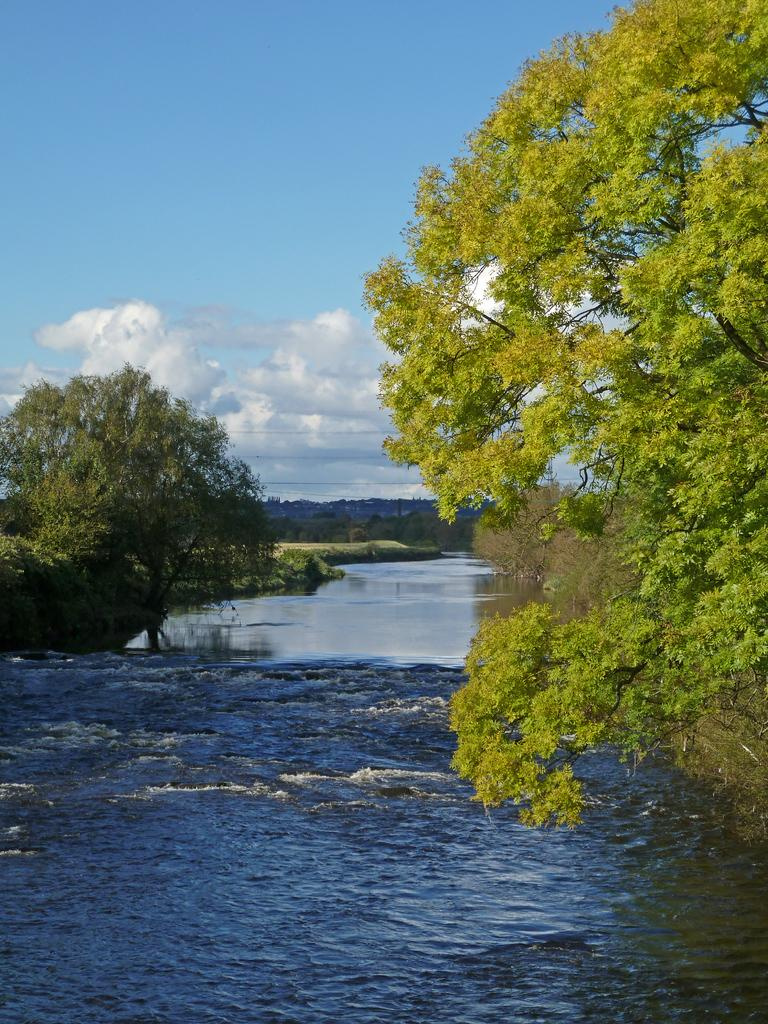What type of natural feature is depicted in the image? There is a river in the image. What surrounds the river on both sides? Trees are present on both sides of the river. What can be seen in the distance behind the river? There is a mountain visible in the background. What is visible above the river and the trees? The sky is visible in the image. What can be observed in the sky? Clouds are present in the sky. What type of agreement is being signed by the governor in the image? There is no governor or agreement present in the image; it features a river, trees, a mountain, and clouds. How many beds are visible in the image? There are no beds present in the image. 